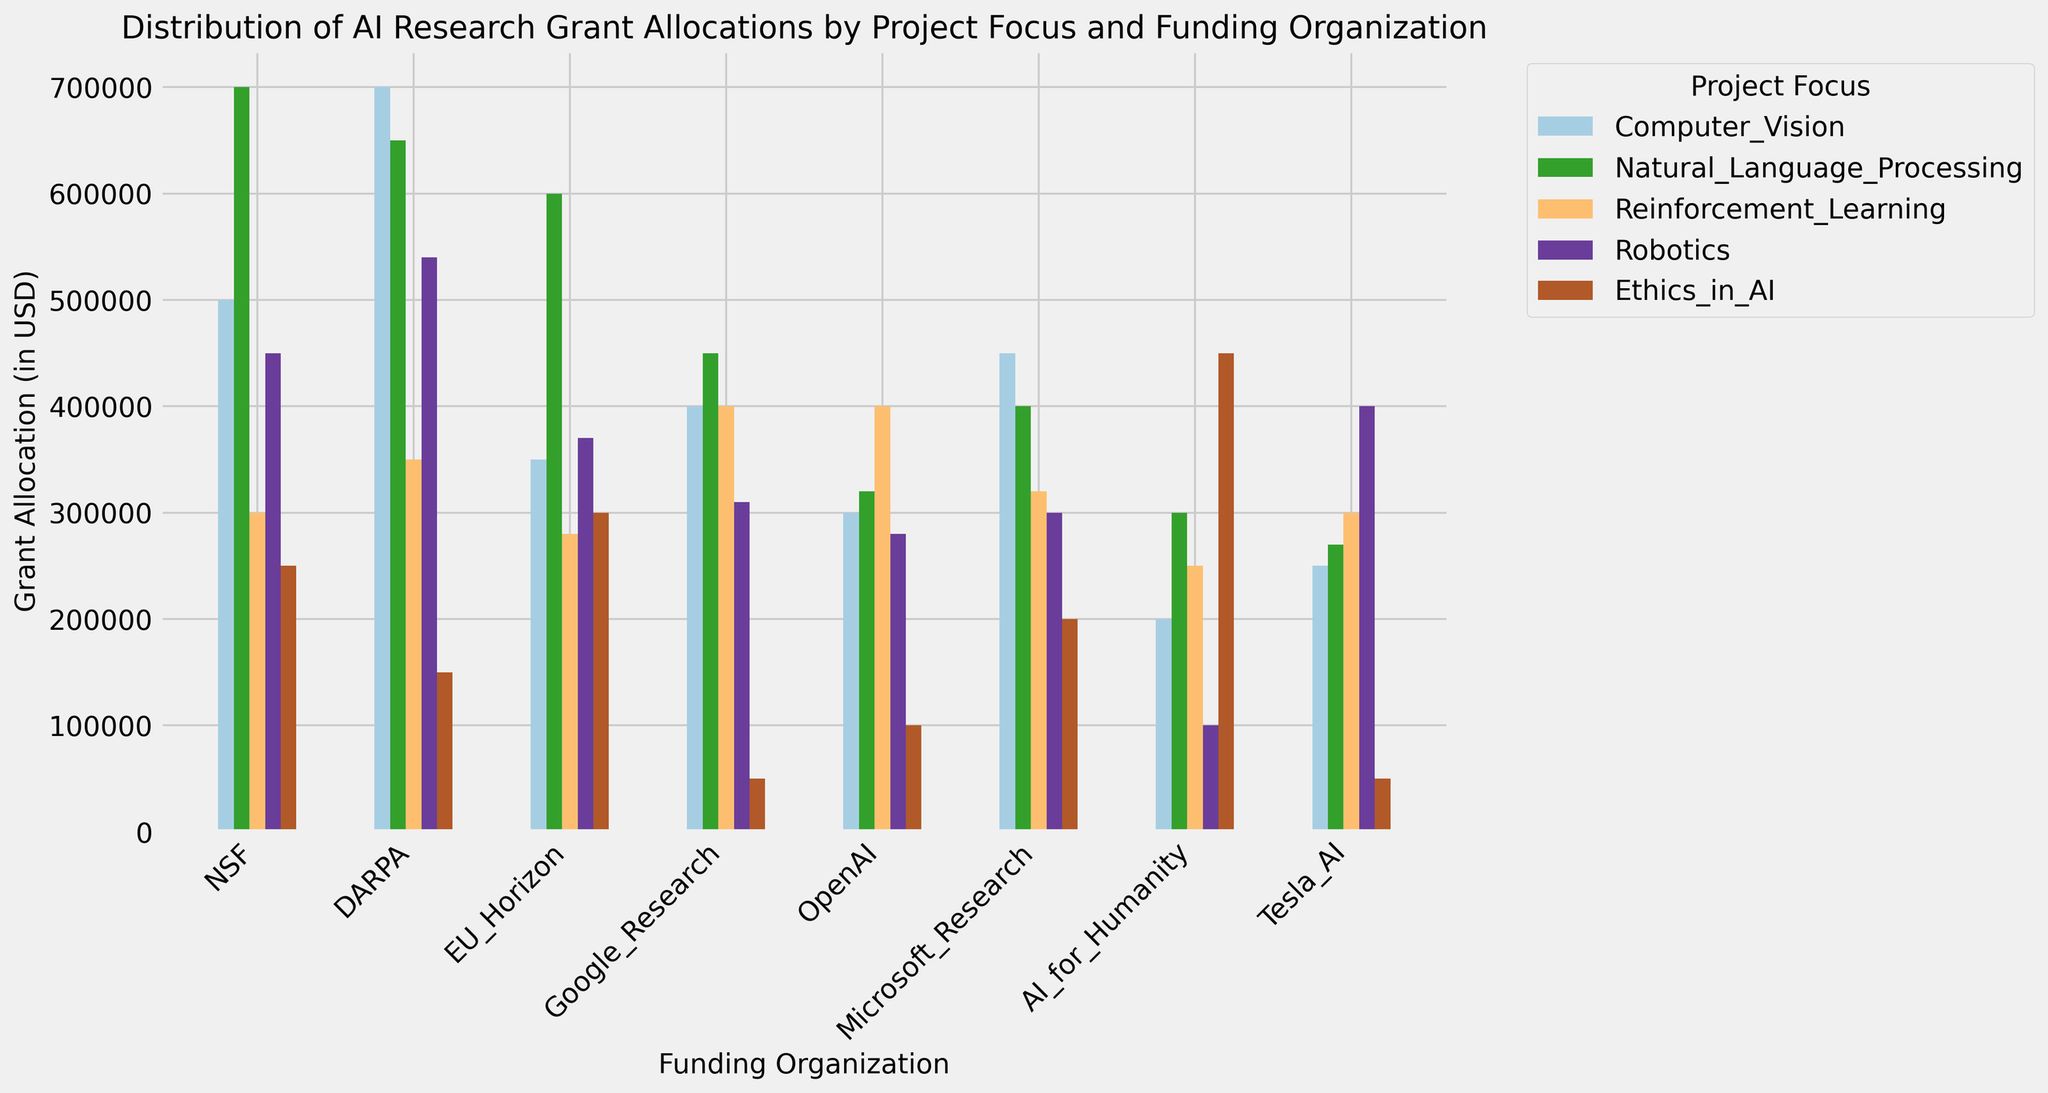What is the highest grant allocation given to Computer Vision among all funding organizations? To find the highest grant allocation for Computer Vision, check the heights of the bars associated with Computer Vision (typically the first bar in each group). The highest bar in the Computer Vision category corresponds to DARPA, which allocates $700,000.
Answer: $700,000 Which organization allocates the smallest amount of funds to Ethics in AI? Look at the final set of bars (Ethics in AI) and identify the shortest one. It is allocated by Tesla AI, which allocates $50,000.
Answer: Tesla AI How much more does NSF allocate to Natural Language Processing compared to OpenAI’s funding for the same category? Compare the heights of the Natural Language Processing bars for NSF and OpenAI. NSF allocates $700,000 while OpenAI allocates $320,000. The difference is $700,000 - $320,000 = $380,000.
Answer: $380,000 Which funding organization has the most evenly distributed funds among all categories? Examine the bars for each organization and see which one has the most consistent heights across all categories. Google Research appears to have similar heights across categories, indicating a more even distribution of funds.
Answer: Google Research Compare the total grant allocations of EU Horizon and AI for Humanity. Which one has higher total funding? Sum the grant allocations for each category for both organizations. EU Horizon's breakdown is (350,000 + 600,000 + 280,000 + 370,000 + 300,000 = 1,900,000) and AI for Humanity (200,000 + 300,000 + 250,000 + 100,000 + 450,000 = 1,300,000). EU Horizon has higher total funding.
Answer: EU Horizon Between Robotics and Reinforcement Learning, which category received more funding from Microsoft Research? Look at the heights of the bars for Microsoft Research in the Robotics and Reinforcement Learning categories. Microsoft Research allocates $300,000 to Robotics and $320,000 to Reinforcement Learning.
Answer: Reinforcement Learning What is the average grant allocation for Ethics in AI across all funding organizations? Sum up all the amounts allocated to Ethics in AI and divide by the number of funding organizations. (250,000 + 150,000 + 300,000 + 50,000 + 100,000 + 200,000 + 450,000 + 50,000 = 1,550,000). There are 8 organizations, so 1,550,000 / 8 = $193,750.
Answer: $193,750 Which organization allocates almost equal amounts to both Robotics and Computer Vision? Look for an organization where the heights of the bars for Robotics and Computer Vision are similar. NSF allocates $500,000 to Computer Vision and $450,000 to Robotics, which are quite close.
Answer: NSF 